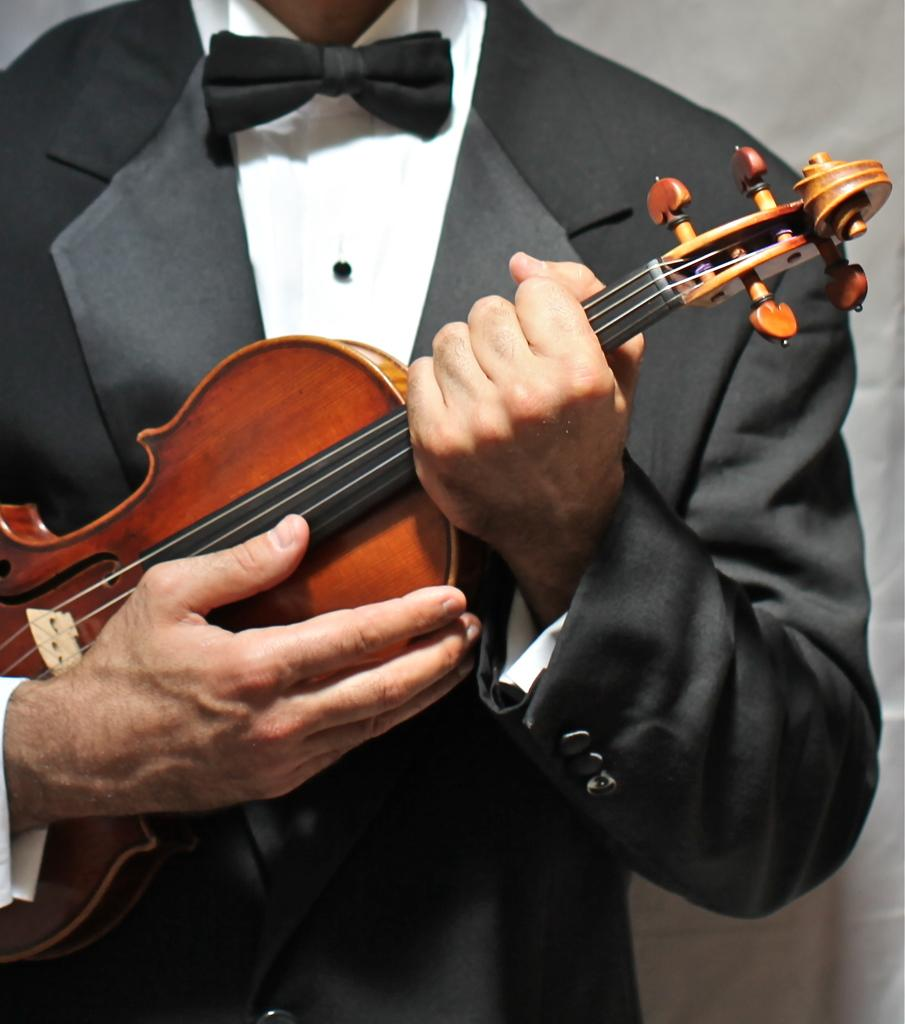What is the main subject of the image? There is a person standing in the center of the image. What is the person wearing? The person is wearing a suit. What is the person holding in his hand? The person is holding a guitar in his hand. Can you see any ghosts interacting with the person in the image? There are no ghosts present in the image. Is the person in the image cooking anything? There is no indication in the image that the person is cooking anything. 